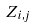<formula> <loc_0><loc_0><loc_500><loc_500>Z _ { i , j }</formula> 